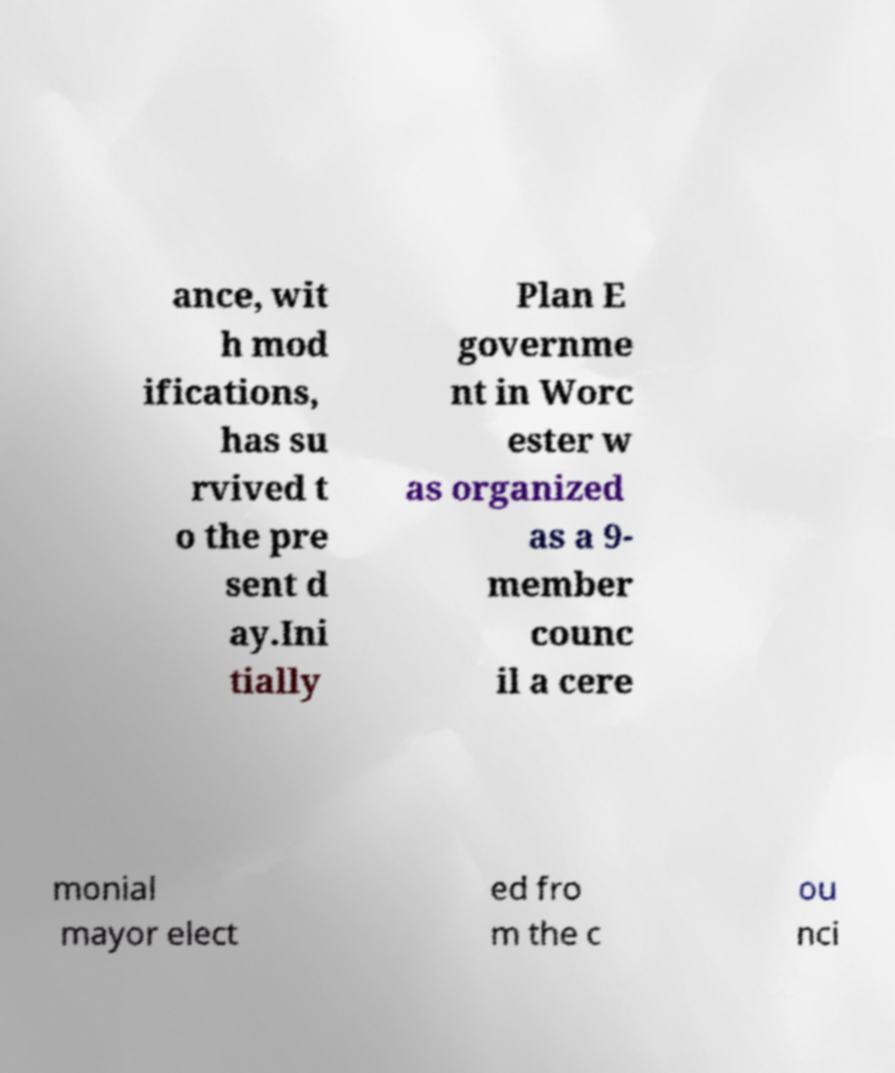What messages or text are displayed in this image? I need them in a readable, typed format. ance, wit h mod ifications, has su rvived t o the pre sent d ay.Ini tially Plan E governme nt in Worc ester w as organized as a 9- member counc il a cere monial mayor elect ed fro m the c ou nci 